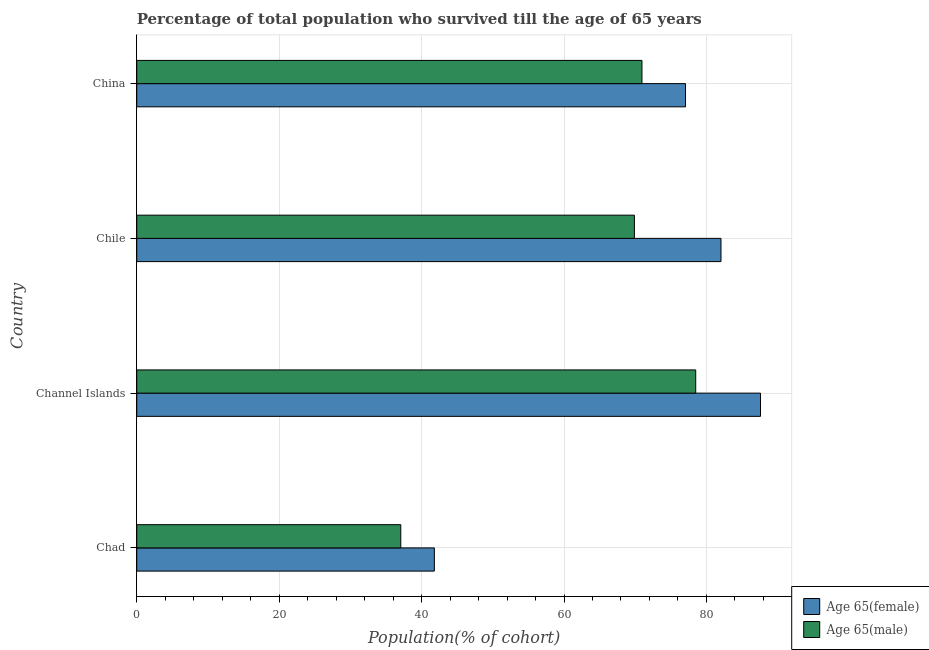How many different coloured bars are there?
Your response must be concise. 2. Are the number of bars per tick equal to the number of legend labels?
Your answer should be very brief. Yes. Are the number of bars on each tick of the Y-axis equal?
Your answer should be compact. Yes. How many bars are there on the 2nd tick from the top?
Your response must be concise. 2. What is the label of the 3rd group of bars from the top?
Your answer should be very brief. Channel Islands. In how many cases, is the number of bars for a given country not equal to the number of legend labels?
Your answer should be very brief. 0. What is the percentage of female population who survived till age of 65 in Chad?
Make the answer very short. 41.79. Across all countries, what is the maximum percentage of female population who survived till age of 65?
Provide a short and direct response. 87.6. Across all countries, what is the minimum percentage of male population who survived till age of 65?
Your answer should be compact. 37.08. In which country was the percentage of female population who survived till age of 65 maximum?
Your response must be concise. Channel Islands. In which country was the percentage of female population who survived till age of 65 minimum?
Ensure brevity in your answer.  Chad. What is the total percentage of female population who survived till age of 65 in the graph?
Your response must be concise. 288.5. What is the difference between the percentage of male population who survived till age of 65 in Chile and that in China?
Your response must be concise. -1.06. What is the difference between the percentage of male population who survived till age of 65 in China and the percentage of female population who survived till age of 65 in Channel Islands?
Offer a very short reply. -16.65. What is the average percentage of male population who survived till age of 65 per country?
Your answer should be compact. 64.1. What is the difference between the percentage of male population who survived till age of 65 and percentage of female population who survived till age of 65 in Channel Islands?
Provide a succinct answer. -9.1. In how many countries, is the percentage of male population who survived till age of 65 greater than 12 %?
Make the answer very short. 4. What is the ratio of the percentage of female population who survived till age of 65 in Channel Islands to that in Chile?
Your response must be concise. 1.07. Is the percentage of male population who survived till age of 65 in Chad less than that in Chile?
Give a very brief answer. Yes. Is the difference between the percentage of female population who survived till age of 65 in Chile and China greater than the difference between the percentage of male population who survived till age of 65 in Chile and China?
Your answer should be very brief. Yes. What is the difference between the highest and the second highest percentage of female population who survived till age of 65?
Offer a terse response. 5.55. What is the difference between the highest and the lowest percentage of female population who survived till age of 65?
Give a very brief answer. 45.8. Is the sum of the percentage of male population who survived till age of 65 in Channel Islands and Chile greater than the maximum percentage of female population who survived till age of 65 across all countries?
Offer a very short reply. Yes. What does the 1st bar from the top in Chad represents?
Offer a terse response. Age 65(male). What does the 2nd bar from the bottom in China represents?
Provide a succinct answer. Age 65(male). How many bars are there?
Provide a short and direct response. 8. Are all the bars in the graph horizontal?
Offer a terse response. Yes. How many countries are there in the graph?
Provide a succinct answer. 4. What is the difference between two consecutive major ticks on the X-axis?
Provide a short and direct response. 20. Are the values on the major ticks of X-axis written in scientific E-notation?
Provide a succinct answer. No. Does the graph contain grids?
Offer a very short reply. Yes. Where does the legend appear in the graph?
Your answer should be compact. Bottom right. How many legend labels are there?
Give a very brief answer. 2. How are the legend labels stacked?
Offer a terse response. Vertical. What is the title of the graph?
Ensure brevity in your answer.  Percentage of total population who survived till the age of 65 years. Does "Long-term debt" appear as one of the legend labels in the graph?
Your answer should be compact. No. What is the label or title of the X-axis?
Offer a very short reply. Population(% of cohort). What is the Population(% of cohort) of Age 65(female) in Chad?
Your answer should be very brief. 41.79. What is the Population(% of cohort) in Age 65(male) in Chad?
Make the answer very short. 37.08. What is the Population(% of cohort) of Age 65(female) in Channel Islands?
Ensure brevity in your answer.  87.6. What is the Population(% of cohort) of Age 65(male) in Channel Islands?
Your answer should be compact. 78.5. What is the Population(% of cohort) of Age 65(female) in Chile?
Make the answer very short. 82.04. What is the Population(% of cohort) of Age 65(male) in Chile?
Your answer should be compact. 69.88. What is the Population(% of cohort) in Age 65(female) in China?
Offer a very short reply. 77.06. What is the Population(% of cohort) of Age 65(male) in China?
Offer a terse response. 70.94. Across all countries, what is the maximum Population(% of cohort) of Age 65(female)?
Offer a very short reply. 87.6. Across all countries, what is the maximum Population(% of cohort) of Age 65(male)?
Your answer should be very brief. 78.5. Across all countries, what is the minimum Population(% of cohort) in Age 65(female)?
Your response must be concise. 41.79. Across all countries, what is the minimum Population(% of cohort) of Age 65(male)?
Your answer should be compact. 37.08. What is the total Population(% of cohort) of Age 65(female) in the graph?
Keep it short and to the point. 288.5. What is the total Population(% of cohort) of Age 65(male) in the graph?
Keep it short and to the point. 256.4. What is the difference between the Population(% of cohort) in Age 65(female) in Chad and that in Channel Islands?
Your response must be concise. -45.8. What is the difference between the Population(% of cohort) in Age 65(male) in Chad and that in Channel Islands?
Your response must be concise. -41.42. What is the difference between the Population(% of cohort) in Age 65(female) in Chad and that in Chile?
Offer a terse response. -40.25. What is the difference between the Population(% of cohort) in Age 65(male) in Chad and that in Chile?
Your response must be concise. -32.81. What is the difference between the Population(% of cohort) in Age 65(female) in Chad and that in China?
Give a very brief answer. -35.27. What is the difference between the Population(% of cohort) in Age 65(male) in Chad and that in China?
Give a very brief answer. -33.87. What is the difference between the Population(% of cohort) of Age 65(female) in Channel Islands and that in Chile?
Keep it short and to the point. 5.55. What is the difference between the Population(% of cohort) of Age 65(male) in Channel Islands and that in Chile?
Your answer should be compact. 8.61. What is the difference between the Population(% of cohort) of Age 65(female) in Channel Islands and that in China?
Ensure brevity in your answer.  10.53. What is the difference between the Population(% of cohort) of Age 65(male) in Channel Islands and that in China?
Offer a terse response. 7.55. What is the difference between the Population(% of cohort) in Age 65(female) in Chile and that in China?
Offer a terse response. 4.98. What is the difference between the Population(% of cohort) of Age 65(male) in Chile and that in China?
Your response must be concise. -1.06. What is the difference between the Population(% of cohort) of Age 65(female) in Chad and the Population(% of cohort) of Age 65(male) in Channel Islands?
Provide a succinct answer. -36.7. What is the difference between the Population(% of cohort) of Age 65(female) in Chad and the Population(% of cohort) of Age 65(male) in Chile?
Your response must be concise. -28.09. What is the difference between the Population(% of cohort) in Age 65(female) in Chad and the Population(% of cohort) in Age 65(male) in China?
Ensure brevity in your answer.  -29.15. What is the difference between the Population(% of cohort) in Age 65(female) in Channel Islands and the Population(% of cohort) in Age 65(male) in Chile?
Your answer should be compact. 17.71. What is the difference between the Population(% of cohort) in Age 65(female) in Channel Islands and the Population(% of cohort) in Age 65(male) in China?
Give a very brief answer. 16.65. What is the difference between the Population(% of cohort) in Age 65(female) in Chile and the Population(% of cohort) in Age 65(male) in China?
Give a very brief answer. 11.1. What is the average Population(% of cohort) in Age 65(female) per country?
Offer a very short reply. 72.12. What is the average Population(% of cohort) of Age 65(male) per country?
Give a very brief answer. 64.1. What is the difference between the Population(% of cohort) of Age 65(female) and Population(% of cohort) of Age 65(male) in Chad?
Your answer should be compact. 4.72. What is the difference between the Population(% of cohort) in Age 65(female) and Population(% of cohort) in Age 65(male) in Channel Islands?
Provide a short and direct response. 9.1. What is the difference between the Population(% of cohort) of Age 65(female) and Population(% of cohort) of Age 65(male) in Chile?
Provide a short and direct response. 12.16. What is the difference between the Population(% of cohort) in Age 65(female) and Population(% of cohort) in Age 65(male) in China?
Keep it short and to the point. 6.12. What is the ratio of the Population(% of cohort) of Age 65(female) in Chad to that in Channel Islands?
Provide a succinct answer. 0.48. What is the ratio of the Population(% of cohort) in Age 65(male) in Chad to that in Channel Islands?
Give a very brief answer. 0.47. What is the ratio of the Population(% of cohort) in Age 65(female) in Chad to that in Chile?
Your answer should be compact. 0.51. What is the ratio of the Population(% of cohort) of Age 65(male) in Chad to that in Chile?
Give a very brief answer. 0.53. What is the ratio of the Population(% of cohort) in Age 65(female) in Chad to that in China?
Provide a succinct answer. 0.54. What is the ratio of the Population(% of cohort) in Age 65(male) in Chad to that in China?
Keep it short and to the point. 0.52. What is the ratio of the Population(% of cohort) of Age 65(female) in Channel Islands to that in Chile?
Give a very brief answer. 1.07. What is the ratio of the Population(% of cohort) in Age 65(male) in Channel Islands to that in Chile?
Give a very brief answer. 1.12. What is the ratio of the Population(% of cohort) in Age 65(female) in Channel Islands to that in China?
Offer a very short reply. 1.14. What is the ratio of the Population(% of cohort) in Age 65(male) in Channel Islands to that in China?
Your answer should be very brief. 1.11. What is the ratio of the Population(% of cohort) of Age 65(female) in Chile to that in China?
Give a very brief answer. 1.06. What is the ratio of the Population(% of cohort) in Age 65(male) in Chile to that in China?
Offer a very short reply. 0.99. What is the difference between the highest and the second highest Population(% of cohort) in Age 65(female)?
Offer a very short reply. 5.55. What is the difference between the highest and the second highest Population(% of cohort) of Age 65(male)?
Make the answer very short. 7.55. What is the difference between the highest and the lowest Population(% of cohort) in Age 65(female)?
Offer a terse response. 45.8. What is the difference between the highest and the lowest Population(% of cohort) in Age 65(male)?
Your answer should be compact. 41.42. 